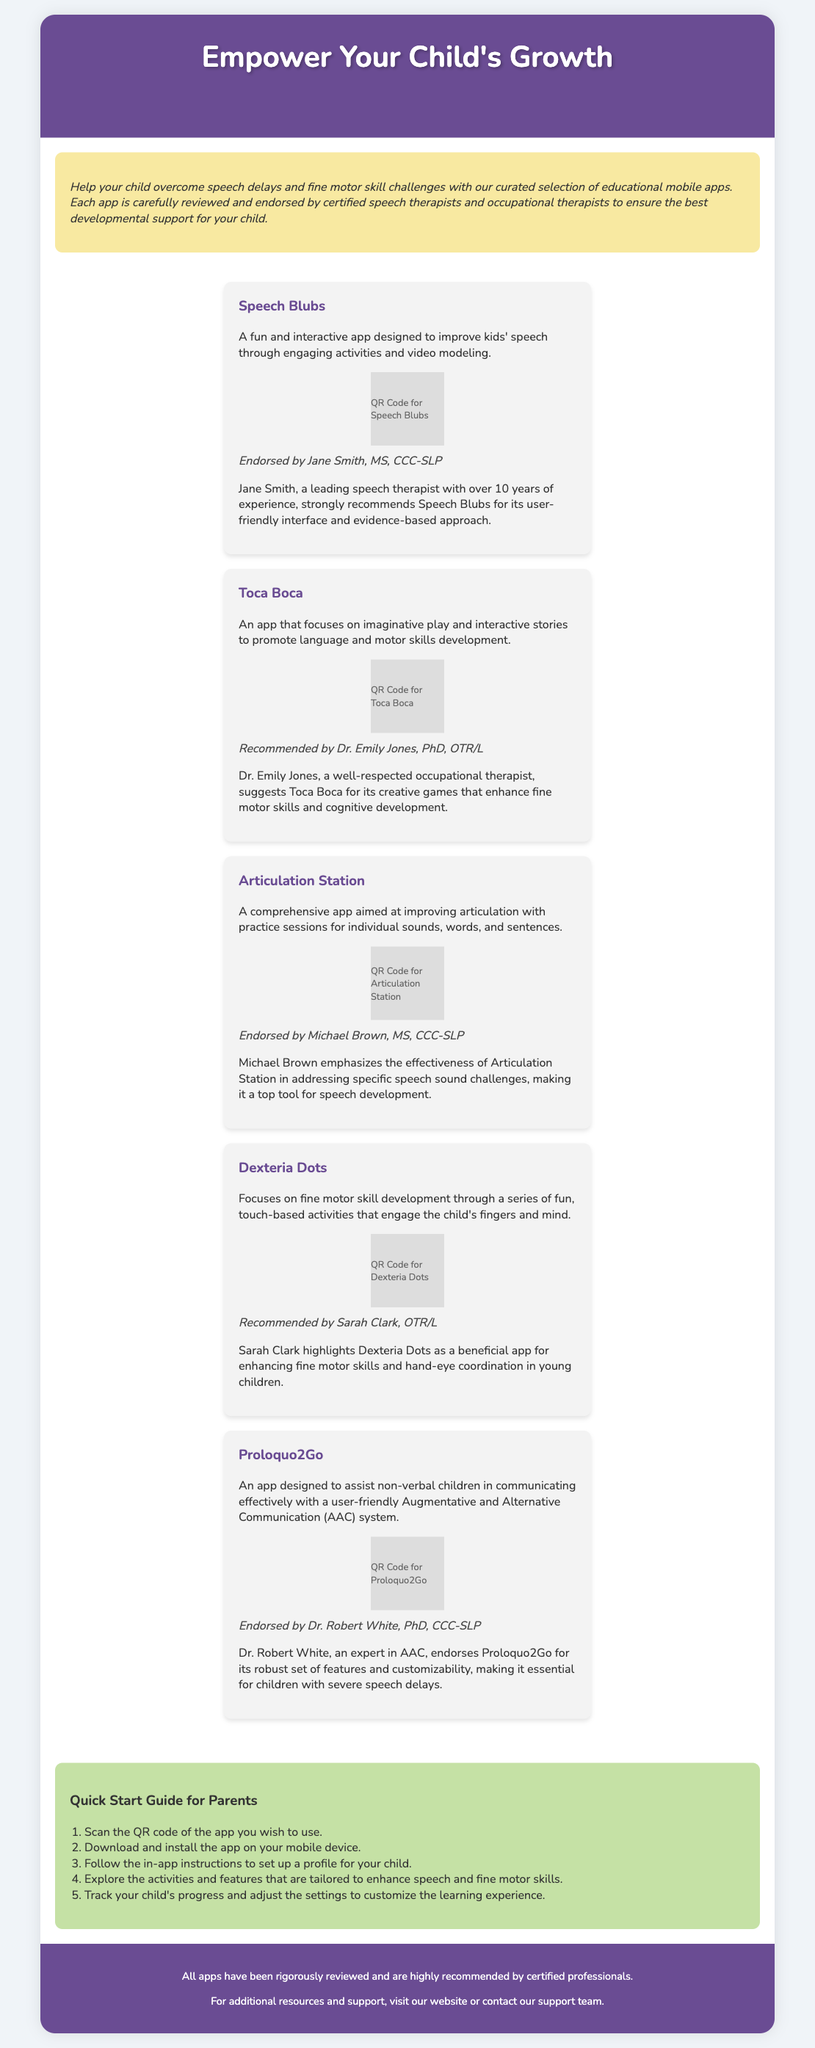What is the title of the document? The title appears at the top of the document in the header section.
Answer: Empower Your Child's Growth How many educational mobile apps are mentioned? The document lists a specific number of apps focused on speech and motor skills, which can be counted in the app section.
Answer: 5 Who endorses the app Speech Blubs? The endorsement for Speech Blubs is provided by a specific professional with credentials mentioned in the document.
Answer: Jane Smith, MS, CCC-SLP What is the main purpose of the apps? The purpose is conveyed in the introductory description of the document, summarizing what the apps aim to achieve.
Answer: Improve speech and fine motor skills What should parents do after scanning the QR code? Parents are given a step-by-step instruction in the user guide section detailing the actions to take.
Answer: Download and install the app Which app focuses on imaginative play? The app for imaginative play is specifically named in the document's app descriptions, allowing for easy identification.
Answer: Toca Boca What background color is used for the user guide section? The document includes design specifications that describe the colors used in various sections.
Answer: Light green (c5e1a5) Who recommends Dexteria Dots? The recommendation comes from a specific occupational therapist mentioned within the app's endorsement section.
Answer: Sarah Clark, OTR/L 